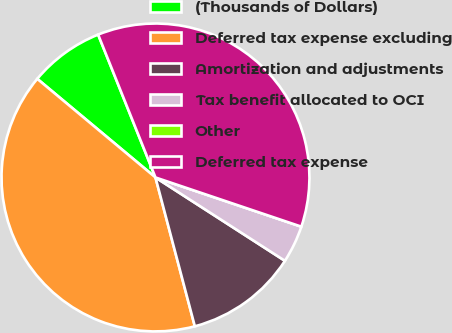<chart> <loc_0><loc_0><loc_500><loc_500><pie_chart><fcel>(Thousands of Dollars)<fcel>Deferred tax expense excluding<fcel>Amortization and adjustments<fcel>Tax benefit allocated to OCI<fcel>Other<fcel>Deferred tax expense<nl><fcel>7.86%<fcel>40.18%<fcel>11.78%<fcel>3.93%<fcel>0.0%<fcel>36.25%<nl></chart> 